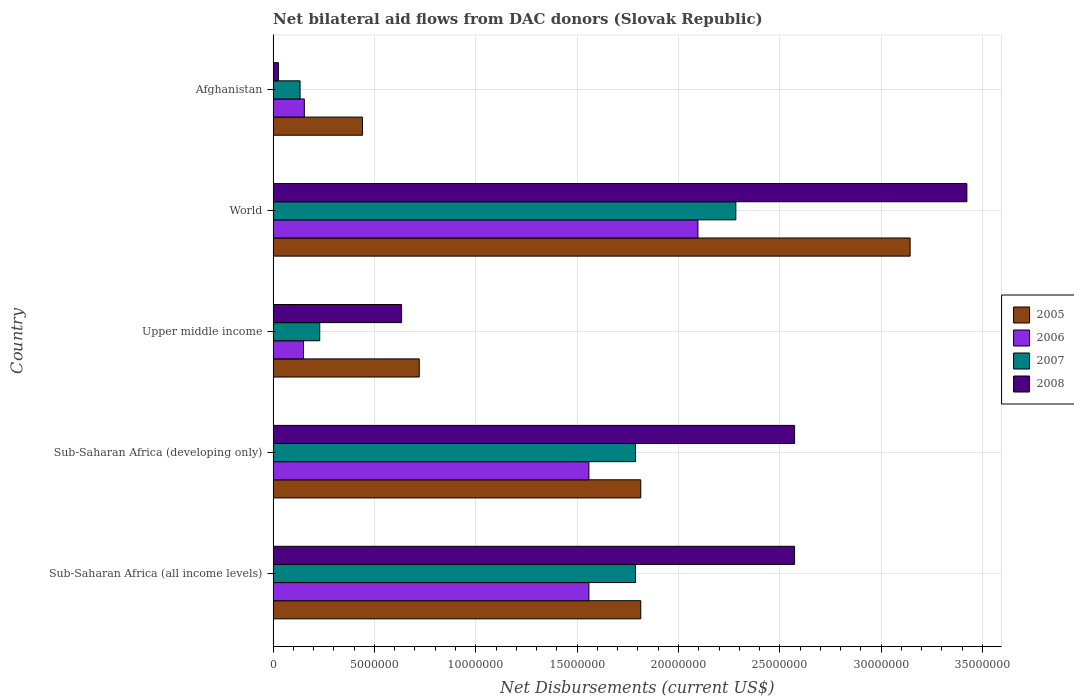How many different coloured bars are there?
Your answer should be compact. 4. Are the number of bars per tick equal to the number of legend labels?
Provide a short and direct response. Yes. Are the number of bars on each tick of the Y-axis equal?
Offer a very short reply. Yes. How many bars are there on the 2nd tick from the top?
Provide a short and direct response. 4. What is the net bilateral aid flows in 2006 in Sub-Saharan Africa (all income levels)?
Make the answer very short. 1.56e+07. Across all countries, what is the maximum net bilateral aid flows in 2005?
Offer a terse response. 3.14e+07. In which country was the net bilateral aid flows in 2005 maximum?
Keep it short and to the point. World. In which country was the net bilateral aid flows in 2006 minimum?
Give a very brief answer. Upper middle income. What is the total net bilateral aid flows in 2005 in the graph?
Ensure brevity in your answer.  7.93e+07. What is the difference between the net bilateral aid flows in 2007 in Upper middle income and that in World?
Ensure brevity in your answer.  -2.05e+07. What is the difference between the net bilateral aid flows in 2006 in Sub-Saharan Africa (all income levels) and the net bilateral aid flows in 2005 in Sub-Saharan Africa (developing only)?
Provide a short and direct response. -2.56e+06. What is the average net bilateral aid flows in 2006 per country?
Provide a succinct answer. 1.10e+07. What is the difference between the net bilateral aid flows in 2008 and net bilateral aid flows in 2006 in Sub-Saharan Africa (all income levels)?
Offer a very short reply. 1.02e+07. What is the ratio of the net bilateral aid flows in 2006 in Afghanistan to that in Sub-Saharan Africa (developing only)?
Give a very brief answer. 0.1. Is the difference between the net bilateral aid flows in 2008 in Afghanistan and Sub-Saharan Africa (developing only) greater than the difference between the net bilateral aid flows in 2006 in Afghanistan and Sub-Saharan Africa (developing only)?
Give a very brief answer. No. What is the difference between the highest and the second highest net bilateral aid flows in 2007?
Your answer should be compact. 4.95e+06. What is the difference between the highest and the lowest net bilateral aid flows in 2008?
Keep it short and to the point. 3.40e+07. In how many countries, is the net bilateral aid flows in 2005 greater than the average net bilateral aid flows in 2005 taken over all countries?
Ensure brevity in your answer.  3. Is the sum of the net bilateral aid flows in 2005 in Sub-Saharan Africa (all income levels) and Sub-Saharan Africa (developing only) greater than the maximum net bilateral aid flows in 2007 across all countries?
Your answer should be compact. Yes. Is it the case that in every country, the sum of the net bilateral aid flows in 2005 and net bilateral aid flows in 2008 is greater than the net bilateral aid flows in 2007?
Your response must be concise. Yes. Are all the bars in the graph horizontal?
Your answer should be compact. Yes. How many countries are there in the graph?
Make the answer very short. 5. Does the graph contain any zero values?
Provide a succinct answer. No. Where does the legend appear in the graph?
Make the answer very short. Center right. What is the title of the graph?
Your response must be concise. Net bilateral aid flows from DAC donors (Slovak Republic). Does "2009" appear as one of the legend labels in the graph?
Give a very brief answer. No. What is the label or title of the X-axis?
Your response must be concise. Net Disbursements (current US$). What is the Net Disbursements (current US$) in 2005 in Sub-Saharan Africa (all income levels)?
Keep it short and to the point. 1.81e+07. What is the Net Disbursements (current US$) in 2006 in Sub-Saharan Africa (all income levels)?
Your answer should be very brief. 1.56e+07. What is the Net Disbursements (current US$) of 2007 in Sub-Saharan Africa (all income levels)?
Provide a succinct answer. 1.79e+07. What is the Net Disbursements (current US$) of 2008 in Sub-Saharan Africa (all income levels)?
Provide a short and direct response. 2.57e+07. What is the Net Disbursements (current US$) in 2005 in Sub-Saharan Africa (developing only)?
Ensure brevity in your answer.  1.81e+07. What is the Net Disbursements (current US$) in 2006 in Sub-Saharan Africa (developing only)?
Make the answer very short. 1.56e+07. What is the Net Disbursements (current US$) of 2007 in Sub-Saharan Africa (developing only)?
Make the answer very short. 1.79e+07. What is the Net Disbursements (current US$) in 2008 in Sub-Saharan Africa (developing only)?
Your answer should be very brief. 2.57e+07. What is the Net Disbursements (current US$) in 2005 in Upper middle income?
Make the answer very short. 7.21e+06. What is the Net Disbursements (current US$) of 2006 in Upper middle income?
Keep it short and to the point. 1.50e+06. What is the Net Disbursements (current US$) in 2007 in Upper middle income?
Offer a terse response. 2.30e+06. What is the Net Disbursements (current US$) of 2008 in Upper middle income?
Your answer should be very brief. 6.34e+06. What is the Net Disbursements (current US$) in 2005 in World?
Give a very brief answer. 3.14e+07. What is the Net Disbursements (current US$) of 2006 in World?
Your answer should be compact. 2.10e+07. What is the Net Disbursements (current US$) in 2007 in World?
Your answer should be very brief. 2.28e+07. What is the Net Disbursements (current US$) in 2008 in World?
Your response must be concise. 3.42e+07. What is the Net Disbursements (current US$) in 2005 in Afghanistan?
Offer a terse response. 4.41e+06. What is the Net Disbursements (current US$) of 2006 in Afghanistan?
Offer a terse response. 1.54e+06. What is the Net Disbursements (current US$) in 2007 in Afghanistan?
Your answer should be compact. 1.33e+06. Across all countries, what is the maximum Net Disbursements (current US$) in 2005?
Provide a succinct answer. 3.14e+07. Across all countries, what is the maximum Net Disbursements (current US$) in 2006?
Make the answer very short. 2.10e+07. Across all countries, what is the maximum Net Disbursements (current US$) in 2007?
Your answer should be compact. 2.28e+07. Across all countries, what is the maximum Net Disbursements (current US$) in 2008?
Offer a very short reply. 3.42e+07. Across all countries, what is the minimum Net Disbursements (current US$) in 2005?
Your answer should be compact. 4.41e+06. Across all countries, what is the minimum Net Disbursements (current US$) in 2006?
Make the answer very short. 1.50e+06. Across all countries, what is the minimum Net Disbursements (current US$) of 2007?
Keep it short and to the point. 1.33e+06. What is the total Net Disbursements (current US$) in 2005 in the graph?
Provide a succinct answer. 7.93e+07. What is the total Net Disbursements (current US$) in 2006 in the graph?
Offer a terse response. 5.52e+07. What is the total Net Disbursements (current US$) of 2007 in the graph?
Make the answer very short. 6.22e+07. What is the total Net Disbursements (current US$) in 2008 in the graph?
Your answer should be compact. 9.23e+07. What is the difference between the Net Disbursements (current US$) of 2005 in Sub-Saharan Africa (all income levels) and that in Upper middle income?
Provide a short and direct response. 1.09e+07. What is the difference between the Net Disbursements (current US$) in 2006 in Sub-Saharan Africa (all income levels) and that in Upper middle income?
Give a very brief answer. 1.41e+07. What is the difference between the Net Disbursements (current US$) of 2007 in Sub-Saharan Africa (all income levels) and that in Upper middle income?
Offer a terse response. 1.56e+07. What is the difference between the Net Disbursements (current US$) in 2008 in Sub-Saharan Africa (all income levels) and that in Upper middle income?
Your answer should be very brief. 1.94e+07. What is the difference between the Net Disbursements (current US$) of 2005 in Sub-Saharan Africa (all income levels) and that in World?
Your response must be concise. -1.33e+07. What is the difference between the Net Disbursements (current US$) of 2006 in Sub-Saharan Africa (all income levels) and that in World?
Your answer should be compact. -5.38e+06. What is the difference between the Net Disbursements (current US$) in 2007 in Sub-Saharan Africa (all income levels) and that in World?
Make the answer very short. -4.95e+06. What is the difference between the Net Disbursements (current US$) of 2008 in Sub-Saharan Africa (all income levels) and that in World?
Provide a succinct answer. -8.50e+06. What is the difference between the Net Disbursements (current US$) of 2005 in Sub-Saharan Africa (all income levels) and that in Afghanistan?
Ensure brevity in your answer.  1.37e+07. What is the difference between the Net Disbursements (current US$) in 2006 in Sub-Saharan Africa (all income levels) and that in Afghanistan?
Offer a terse response. 1.40e+07. What is the difference between the Net Disbursements (current US$) of 2007 in Sub-Saharan Africa (all income levels) and that in Afghanistan?
Provide a short and direct response. 1.66e+07. What is the difference between the Net Disbursements (current US$) of 2008 in Sub-Saharan Africa (all income levels) and that in Afghanistan?
Keep it short and to the point. 2.55e+07. What is the difference between the Net Disbursements (current US$) of 2005 in Sub-Saharan Africa (developing only) and that in Upper middle income?
Make the answer very short. 1.09e+07. What is the difference between the Net Disbursements (current US$) in 2006 in Sub-Saharan Africa (developing only) and that in Upper middle income?
Ensure brevity in your answer.  1.41e+07. What is the difference between the Net Disbursements (current US$) of 2007 in Sub-Saharan Africa (developing only) and that in Upper middle income?
Give a very brief answer. 1.56e+07. What is the difference between the Net Disbursements (current US$) in 2008 in Sub-Saharan Africa (developing only) and that in Upper middle income?
Your response must be concise. 1.94e+07. What is the difference between the Net Disbursements (current US$) of 2005 in Sub-Saharan Africa (developing only) and that in World?
Ensure brevity in your answer.  -1.33e+07. What is the difference between the Net Disbursements (current US$) of 2006 in Sub-Saharan Africa (developing only) and that in World?
Ensure brevity in your answer.  -5.38e+06. What is the difference between the Net Disbursements (current US$) in 2007 in Sub-Saharan Africa (developing only) and that in World?
Ensure brevity in your answer.  -4.95e+06. What is the difference between the Net Disbursements (current US$) in 2008 in Sub-Saharan Africa (developing only) and that in World?
Ensure brevity in your answer.  -8.50e+06. What is the difference between the Net Disbursements (current US$) of 2005 in Sub-Saharan Africa (developing only) and that in Afghanistan?
Provide a short and direct response. 1.37e+07. What is the difference between the Net Disbursements (current US$) of 2006 in Sub-Saharan Africa (developing only) and that in Afghanistan?
Your response must be concise. 1.40e+07. What is the difference between the Net Disbursements (current US$) of 2007 in Sub-Saharan Africa (developing only) and that in Afghanistan?
Keep it short and to the point. 1.66e+07. What is the difference between the Net Disbursements (current US$) of 2008 in Sub-Saharan Africa (developing only) and that in Afghanistan?
Provide a short and direct response. 2.55e+07. What is the difference between the Net Disbursements (current US$) of 2005 in Upper middle income and that in World?
Your answer should be very brief. -2.42e+07. What is the difference between the Net Disbursements (current US$) in 2006 in Upper middle income and that in World?
Provide a succinct answer. -1.95e+07. What is the difference between the Net Disbursements (current US$) of 2007 in Upper middle income and that in World?
Ensure brevity in your answer.  -2.05e+07. What is the difference between the Net Disbursements (current US$) of 2008 in Upper middle income and that in World?
Offer a very short reply. -2.79e+07. What is the difference between the Net Disbursements (current US$) of 2005 in Upper middle income and that in Afghanistan?
Offer a very short reply. 2.80e+06. What is the difference between the Net Disbursements (current US$) in 2007 in Upper middle income and that in Afghanistan?
Keep it short and to the point. 9.70e+05. What is the difference between the Net Disbursements (current US$) of 2008 in Upper middle income and that in Afghanistan?
Keep it short and to the point. 6.08e+06. What is the difference between the Net Disbursements (current US$) in 2005 in World and that in Afghanistan?
Offer a terse response. 2.70e+07. What is the difference between the Net Disbursements (current US$) of 2006 in World and that in Afghanistan?
Provide a succinct answer. 1.94e+07. What is the difference between the Net Disbursements (current US$) of 2007 in World and that in Afghanistan?
Your answer should be compact. 2.15e+07. What is the difference between the Net Disbursements (current US$) of 2008 in World and that in Afghanistan?
Offer a very short reply. 3.40e+07. What is the difference between the Net Disbursements (current US$) of 2005 in Sub-Saharan Africa (all income levels) and the Net Disbursements (current US$) of 2006 in Sub-Saharan Africa (developing only)?
Offer a very short reply. 2.56e+06. What is the difference between the Net Disbursements (current US$) in 2005 in Sub-Saharan Africa (all income levels) and the Net Disbursements (current US$) in 2007 in Sub-Saharan Africa (developing only)?
Your response must be concise. 2.60e+05. What is the difference between the Net Disbursements (current US$) in 2005 in Sub-Saharan Africa (all income levels) and the Net Disbursements (current US$) in 2008 in Sub-Saharan Africa (developing only)?
Offer a terse response. -7.59e+06. What is the difference between the Net Disbursements (current US$) in 2006 in Sub-Saharan Africa (all income levels) and the Net Disbursements (current US$) in 2007 in Sub-Saharan Africa (developing only)?
Offer a terse response. -2.30e+06. What is the difference between the Net Disbursements (current US$) of 2006 in Sub-Saharan Africa (all income levels) and the Net Disbursements (current US$) of 2008 in Sub-Saharan Africa (developing only)?
Your answer should be compact. -1.02e+07. What is the difference between the Net Disbursements (current US$) in 2007 in Sub-Saharan Africa (all income levels) and the Net Disbursements (current US$) in 2008 in Sub-Saharan Africa (developing only)?
Give a very brief answer. -7.85e+06. What is the difference between the Net Disbursements (current US$) of 2005 in Sub-Saharan Africa (all income levels) and the Net Disbursements (current US$) of 2006 in Upper middle income?
Keep it short and to the point. 1.66e+07. What is the difference between the Net Disbursements (current US$) in 2005 in Sub-Saharan Africa (all income levels) and the Net Disbursements (current US$) in 2007 in Upper middle income?
Ensure brevity in your answer.  1.58e+07. What is the difference between the Net Disbursements (current US$) of 2005 in Sub-Saharan Africa (all income levels) and the Net Disbursements (current US$) of 2008 in Upper middle income?
Provide a short and direct response. 1.18e+07. What is the difference between the Net Disbursements (current US$) in 2006 in Sub-Saharan Africa (all income levels) and the Net Disbursements (current US$) in 2007 in Upper middle income?
Ensure brevity in your answer.  1.33e+07. What is the difference between the Net Disbursements (current US$) in 2006 in Sub-Saharan Africa (all income levels) and the Net Disbursements (current US$) in 2008 in Upper middle income?
Provide a succinct answer. 9.24e+06. What is the difference between the Net Disbursements (current US$) in 2007 in Sub-Saharan Africa (all income levels) and the Net Disbursements (current US$) in 2008 in Upper middle income?
Provide a succinct answer. 1.15e+07. What is the difference between the Net Disbursements (current US$) in 2005 in Sub-Saharan Africa (all income levels) and the Net Disbursements (current US$) in 2006 in World?
Ensure brevity in your answer.  -2.82e+06. What is the difference between the Net Disbursements (current US$) in 2005 in Sub-Saharan Africa (all income levels) and the Net Disbursements (current US$) in 2007 in World?
Provide a short and direct response. -4.69e+06. What is the difference between the Net Disbursements (current US$) in 2005 in Sub-Saharan Africa (all income levels) and the Net Disbursements (current US$) in 2008 in World?
Provide a succinct answer. -1.61e+07. What is the difference between the Net Disbursements (current US$) of 2006 in Sub-Saharan Africa (all income levels) and the Net Disbursements (current US$) of 2007 in World?
Provide a short and direct response. -7.25e+06. What is the difference between the Net Disbursements (current US$) in 2006 in Sub-Saharan Africa (all income levels) and the Net Disbursements (current US$) in 2008 in World?
Make the answer very short. -1.86e+07. What is the difference between the Net Disbursements (current US$) in 2007 in Sub-Saharan Africa (all income levels) and the Net Disbursements (current US$) in 2008 in World?
Make the answer very short. -1.64e+07. What is the difference between the Net Disbursements (current US$) of 2005 in Sub-Saharan Africa (all income levels) and the Net Disbursements (current US$) of 2006 in Afghanistan?
Offer a very short reply. 1.66e+07. What is the difference between the Net Disbursements (current US$) in 2005 in Sub-Saharan Africa (all income levels) and the Net Disbursements (current US$) in 2007 in Afghanistan?
Ensure brevity in your answer.  1.68e+07. What is the difference between the Net Disbursements (current US$) of 2005 in Sub-Saharan Africa (all income levels) and the Net Disbursements (current US$) of 2008 in Afghanistan?
Offer a very short reply. 1.79e+07. What is the difference between the Net Disbursements (current US$) in 2006 in Sub-Saharan Africa (all income levels) and the Net Disbursements (current US$) in 2007 in Afghanistan?
Provide a short and direct response. 1.42e+07. What is the difference between the Net Disbursements (current US$) of 2006 in Sub-Saharan Africa (all income levels) and the Net Disbursements (current US$) of 2008 in Afghanistan?
Your response must be concise. 1.53e+07. What is the difference between the Net Disbursements (current US$) in 2007 in Sub-Saharan Africa (all income levels) and the Net Disbursements (current US$) in 2008 in Afghanistan?
Your answer should be very brief. 1.76e+07. What is the difference between the Net Disbursements (current US$) of 2005 in Sub-Saharan Africa (developing only) and the Net Disbursements (current US$) of 2006 in Upper middle income?
Make the answer very short. 1.66e+07. What is the difference between the Net Disbursements (current US$) of 2005 in Sub-Saharan Africa (developing only) and the Net Disbursements (current US$) of 2007 in Upper middle income?
Offer a very short reply. 1.58e+07. What is the difference between the Net Disbursements (current US$) of 2005 in Sub-Saharan Africa (developing only) and the Net Disbursements (current US$) of 2008 in Upper middle income?
Ensure brevity in your answer.  1.18e+07. What is the difference between the Net Disbursements (current US$) of 2006 in Sub-Saharan Africa (developing only) and the Net Disbursements (current US$) of 2007 in Upper middle income?
Keep it short and to the point. 1.33e+07. What is the difference between the Net Disbursements (current US$) of 2006 in Sub-Saharan Africa (developing only) and the Net Disbursements (current US$) of 2008 in Upper middle income?
Provide a short and direct response. 9.24e+06. What is the difference between the Net Disbursements (current US$) of 2007 in Sub-Saharan Africa (developing only) and the Net Disbursements (current US$) of 2008 in Upper middle income?
Give a very brief answer. 1.15e+07. What is the difference between the Net Disbursements (current US$) of 2005 in Sub-Saharan Africa (developing only) and the Net Disbursements (current US$) of 2006 in World?
Make the answer very short. -2.82e+06. What is the difference between the Net Disbursements (current US$) of 2005 in Sub-Saharan Africa (developing only) and the Net Disbursements (current US$) of 2007 in World?
Provide a short and direct response. -4.69e+06. What is the difference between the Net Disbursements (current US$) of 2005 in Sub-Saharan Africa (developing only) and the Net Disbursements (current US$) of 2008 in World?
Your response must be concise. -1.61e+07. What is the difference between the Net Disbursements (current US$) in 2006 in Sub-Saharan Africa (developing only) and the Net Disbursements (current US$) in 2007 in World?
Give a very brief answer. -7.25e+06. What is the difference between the Net Disbursements (current US$) in 2006 in Sub-Saharan Africa (developing only) and the Net Disbursements (current US$) in 2008 in World?
Your answer should be compact. -1.86e+07. What is the difference between the Net Disbursements (current US$) of 2007 in Sub-Saharan Africa (developing only) and the Net Disbursements (current US$) of 2008 in World?
Offer a terse response. -1.64e+07. What is the difference between the Net Disbursements (current US$) in 2005 in Sub-Saharan Africa (developing only) and the Net Disbursements (current US$) in 2006 in Afghanistan?
Provide a short and direct response. 1.66e+07. What is the difference between the Net Disbursements (current US$) in 2005 in Sub-Saharan Africa (developing only) and the Net Disbursements (current US$) in 2007 in Afghanistan?
Ensure brevity in your answer.  1.68e+07. What is the difference between the Net Disbursements (current US$) of 2005 in Sub-Saharan Africa (developing only) and the Net Disbursements (current US$) of 2008 in Afghanistan?
Your answer should be very brief. 1.79e+07. What is the difference between the Net Disbursements (current US$) of 2006 in Sub-Saharan Africa (developing only) and the Net Disbursements (current US$) of 2007 in Afghanistan?
Offer a very short reply. 1.42e+07. What is the difference between the Net Disbursements (current US$) in 2006 in Sub-Saharan Africa (developing only) and the Net Disbursements (current US$) in 2008 in Afghanistan?
Provide a short and direct response. 1.53e+07. What is the difference between the Net Disbursements (current US$) in 2007 in Sub-Saharan Africa (developing only) and the Net Disbursements (current US$) in 2008 in Afghanistan?
Keep it short and to the point. 1.76e+07. What is the difference between the Net Disbursements (current US$) of 2005 in Upper middle income and the Net Disbursements (current US$) of 2006 in World?
Ensure brevity in your answer.  -1.38e+07. What is the difference between the Net Disbursements (current US$) in 2005 in Upper middle income and the Net Disbursements (current US$) in 2007 in World?
Provide a short and direct response. -1.56e+07. What is the difference between the Net Disbursements (current US$) of 2005 in Upper middle income and the Net Disbursements (current US$) of 2008 in World?
Provide a short and direct response. -2.70e+07. What is the difference between the Net Disbursements (current US$) of 2006 in Upper middle income and the Net Disbursements (current US$) of 2007 in World?
Offer a terse response. -2.13e+07. What is the difference between the Net Disbursements (current US$) of 2006 in Upper middle income and the Net Disbursements (current US$) of 2008 in World?
Offer a very short reply. -3.27e+07. What is the difference between the Net Disbursements (current US$) of 2007 in Upper middle income and the Net Disbursements (current US$) of 2008 in World?
Offer a very short reply. -3.19e+07. What is the difference between the Net Disbursements (current US$) of 2005 in Upper middle income and the Net Disbursements (current US$) of 2006 in Afghanistan?
Provide a short and direct response. 5.67e+06. What is the difference between the Net Disbursements (current US$) of 2005 in Upper middle income and the Net Disbursements (current US$) of 2007 in Afghanistan?
Your response must be concise. 5.88e+06. What is the difference between the Net Disbursements (current US$) in 2005 in Upper middle income and the Net Disbursements (current US$) in 2008 in Afghanistan?
Your response must be concise. 6.95e+06. What is the difference between the Net Disbursements (current US$) in 2006 in Upper middle income and the Net Disbursements (current US$) in 2007 in Afghanistan?
Keep it short and to the point. 1.70e+05. What is the difference between the Net Disbursements (current US$) of 2006 in Upper middle income and the Net Disbursements (current US$) of 2008 in Afghanistan?
Give a very brief answer. 1.24e+06. What is the difference between the Net Disbursements (current US$) of 2007 in Upper middle income and the Net Disbursements (current US$) of 2008 in Afghanistan?
Ensure brevity in your answer.  2.04e+06. What is the difference between the Net Disbursements (current US$) of 2005 in World and the Net Disbursements (current US$) of 2006 in Afghanistan?
Offer a terse response. 2.99e+07. What is the difference between the Net Disbursements (current US$) of 2005 in World and the Net Disbursements (current US$) of 2007 in Afghanistan?
Your response must be concise. 3.01e+07. What is the difference between the Net Disbursements (current US$) in 2005 in World and the Net Disbursements (current US$) in 2008 in Afghanistan?
Offer a terse response. 3.12e+07. What is the difference between the Net Disbursements (current US$) in 2006 in World and the Net Disbursements (current US$) in 2007 in Afghanistan?
Offer a very short reply. 1.96e+07. What is the difference between the Net Disbursements (current US$) of 2006 in World and the Net Disbursements (current US$) of 2008 in Afghanistan?
Offer a very short reply. 2.07e+07. What is the difference between the Net Disbursements (current US$) of 2007 in World and the Net Disbursements (current US$) of 2008 in Afghanistan?
Keep it short and to the point. 2.26e+07. What is the average Net Disbursements (current US$) of 2005 per country?
Provide a short and direct response. 1.59e+07. What is the average Net Disbursements (current US$) in 2006 per country?
Offer a terse response. 1.10e+07. What is the average Net Disbursements (current US$) in 2007 per country?
Provide a succinct answer. 1.24e+07. What is the average Net Disbursements (current US$) in 2008 per country?
Give a very brief answer. 1.85e+07. What is the difference between the Net Disbursements (current US$) in 2005 and Net Disbursements (current US$) in 2006 in Sub-Saharan Africa (all income levels)?
Provide a succinct answer. 2.56e+06. What is the difference between the Net Disbursements (current US$) of 2005 and Net Disbursements (current US$) of 2008 in Sub-Saharan Africa (all income levels)?
Your answer should be compact. -7.59e+06. What is the difference between the Net Disbursements (current US$) of 2006 and Net Disbursements (current US$) of 2007 in Sub-Saharan Africa (all income levels)?
Give a very brief answer. -2.30e+06. What is the difference between the Net Disbursements (current US$) of 2006 and Net Disbursements (current US$) of 2008 in Sub-Saharan Africa (all income levels)?
Offer a terse response. -1.02e+07. What is the difference between the Net Disbursements (current US$) of 2007 and Net Disbursements (current US$) of 2008 in Sub-Saharan Africa (all income levels)?
Offer a terse response. -7.85e+06. What is the difference between the Net Disbursements (current US$) in 2005 and Net Disbursements (current US$) in 2006 in Sub-Saharan Africa (developing only)?
Make the answer very short. 2.56e+06. What is the difference between the Net Disbursements (current US$) in 2005 and Net Disbursements (current US$) in 2008 in Sub-Saharan Africa (developing only)?
Provide a short and direct response. -7.59e+06. What is the difference between the Net Disbursements (current US$) of 2006 and Net Disbursements (current US$) of 2007 in Sub-Saharan Africa (developing only)?
Keep it short and to the point. -2.30e+06. What is the difference between the Net Disbursements (current US$) in 2006 and Net Disbursements (current US$) in 2008 in Sub-Saharan Africa (developing only)?
Your answer should be very brief. -1.02e+07. What is the difference between the Net Disbursements (current US$) in 2007 and Net Disbursements (current US$) in 2008 in Sub-Saharan Africa (developing only)?
Offer a very short reply. -7.85e+06. What is the difference between the Net Disbursements (current US$) in 2005 and Net Disbursements (current US$) in 2006 in Upper middle income?
Keep it short and to the point. 5.71e+06. What is the difference between the Net Disbursements (current US$) in 2005 and Net Disbursements (current US$) in 2007 in Upper middle income?
Keep it short and to the point. 4.91e+06. What is the difference between the Net Disbursements (current US$) in 2005 and Net Disbursements (current US$) in 2008 in Upper middle income?
Make the answer very short. 8.70e+05. What is the difference between the Net Disbursements (current US$) of 2006 and Net Disbursements (current US$) of 2007 in Upper middle income?
Your response must be concise. -8.00e+05. What is the difference between the Net Disbursements (current US$) in 2006 and Net Disbursements (current US$) in 2008 in Upper middle income?
Provide a short and direct response. -4.84e+06. What is the difference between the Net Disbursements (current US$) in 2007 and Net Disbursements (current US$) in 2008 in Upper middle income?
Ensure brevity in your answer.  -4.04e+06. What is the difference between the Net Disbursements (current US$) in 2005 and Net Disbursements (current US$) in 2006 in World?
Ensure brevity in your answer.  1.05e+07. What is the difference between the Net Disbursements (current US$) in 2005 and Net Disbursements (current US$) in 2007 in World?
Offer a very short reply. 8.60e+06. What is the difference between the Net Disbursements (current US$) in 2005 and Net Disbursements (current US$) in 2008 in World?
Provide a short and direct response. -2.80e+06. What is the difference between the Net Disbursements (current US$) of 2006 and Net Disbursements (current US$) of 2007 in World?
Make the answer very short. -1.87e+06. What is the difference between the Net Disbursements (current US$) in 2006 and Net Disbursements (current US$) in 2008 in World?
Provide a short and direct response. -1.33e+07. What is the difference between the Net Disbursements (current US$) in 2007 and Net Disbursements (current US$) in 2008 in World?
Provide a succinct answer. -1.14e+07. What is the difference between the Net Disbursements (current US$) in 2005 and Net Disbursements (current US$) in 2006 in Afghanistan?
Your answer should be compact. 2.87e+06. What is the difference between the Net Disbursements (current US$) in 2005 and Net Disbursements (current US$) in 2007 in Afghanistan?
Give a very brief answer. 3.08e+06. What is the difference between the Net Disbursements (current US$) in 2005 and Net Disbursements (current US$) in 2008 in Afghanistan?
Keep it short and to the point. 4.15e+06. What is the difference between the Net Disbursements (current US$) in 2006 and Net Disbursements (current US$) in 2007 in Afghanistan?
Provide a succinct answer. 2.10e+05. What is the difference between the Net Disbursements (current US$) of 2006 and Net Disbursements (current US$) of 2008 in Afghanistan?
Provide a succinct answer. 1.28e+06. What is the difference between the Net Disbursements (current US$) of 2007 and Net Disbursements (current US$) of 2008 in Afghanistan?
Your answer should be compact. 1.07e+06. What is the ratio of the Net Disbursements (current US$) of 2005 in Sub-Saharan Africa (all income levels) to that in Sub-Saharan Africa (developing only)?
Ensure brevity in your answer.  1. What is the ratio of the Net Disbursements (current US$) in 2007 in Sub-Saharan Africa (all income levels) to that in Sub-Saharan Africa (developing only)?
Keep it short and to the point. 1. What is the ratio of the Net Disbursements (current US$) in 2005 in Sub-Saharan Africa (all income levels) to that in Upper middle income?
Your answer should be compact. 2.52. What is the ratio of the Net Disbursements (current US$) in 2006 in Sub-Saharan Africa (all income levels) to that in Upper middle income?
Provide a succinct answer. 10.39. What is the ratio of the Net Disbursements (current US$) of 2007 in Sub-Saharan Africa (all income levels) to that in Upper middle income?
Give a very brief answer. 7.77. What is the ratio of the Net Disbursements (current US$) in 2008 in Sub-Saharan Africa (all income levels) to that in Upper middle income?
Ensure brevity in your answer.  4.06. What is the ratio of the Net Disbursements (current US$) of 2005 in Sub-Saharan Africa (all income levels) to that in World?
Your response must be concise. 0.58. What is the ratio of the Net Disbursements (current US$) in 2006 in Sub-Saharan Africa (all income levels) to that in World?
Your response must be concise. 0.74. What is the ratio of the Net Disbursements (current US$) of 2007 in Sub-Saharan Africa (all income levels) to that in World?
Give a very brief answer. 0.78. What is the ratio of the Net Disbursements (current US$) of 2008 in Sub-Saharan Africa (all income levels) to that in World?
Give a very brief answer. 0.75. What is the ratio of the Net Disbursements (current US$) in 2005 in Sub-Saharan Africa (all income levels) to that in Afghanistan?
Keep it short and to the point. 4.11. What is the ratio of the Net Disbursements (current US$) in 2006 in Sub-Saharan Africa (all income levels) to that in Afghanistan?
Your answer should be compact. 10.12. What is the ratio of the Net Disbursements (current US$) in 2007 in Sub-Saharan Africa (all income levels) to that in Afghanistan?
Provide a short and direct response. 13.44. What is the ratio of the Net Disbursements (current US$) of 2008 in Sub-Saharan Africa (all income levels) to that in Afghanistan?
Provide a succinct answer. 98.96. What is the ratio of the Net Disbursements (current US$) of 2005 in Sub-Saharan Africa (developing only) to that in Upper middle income?
Make the answer very short. 2.52. What is the ratio of the Net Disbursements (current US$) of 2006 in Sub-Saharan Africa (developing only) to that in Upper middle income?
Your answer should be very brief. 10.39. What is the ratio of the Net Disbursements (current US$) in 2007 in Sub-Saharan Africa (developing only) to that in Upper middle income?
Offer a terse response. 7.77. What is the ratio of the Net Disbursements (current US$) in 2008 in Sub-Saharan Africa (developing only) to that in Upper middle income?
Keep it short and to the point. 4.06. What is the ratio of the Net Disbursements (current US$) of 2005 in Sub-Saharan Africa (developing only) to that in World?
Provide a short and direct response. 0.58. What is the ratio of the Net Disbursements (current US$) of 2006 in Sub-Saharan Africa (developing only) to that in World?
Ensure brevity in your answer.  0.74. What is the ratio of the Net Disbursements (current US$) in 2007 in Sub-Saharan Africa (developing only) to that in World?
Your answer should be compact. 0.78. What is the ratio of the Net Disbursements (current US$) in 2008 in Sub-Saharan Africa (developing only) to that in World?
Provide a succinct answer. 0.75. What is the ratio of the Net Disbursements (current US$) in 2005 in Sub-Saharan Africa (developing only) to that in Afghanistan?
Ensure brevity in your answer.  4.11. What is the ratio of the Net Disbursements (current US$) in 2006 in Sub-Saharan Africa (developing only) to that in Afghanistan?
Make the answer very short. 10.12. What is the ratio of the Net Disbursements (current US$) of 2007 in Sub-Saharan Africa (developing only) to that in Afghanistan?
Your answer should be very brief. 13.44. What is the ratio of the Net Disbursements (current US$) of 2008 in Sub-Saharan Africa (developing only) to that in Afghanistan?
Offer a terse response. 98.96. What is the ratio of the Net Disbursements (current US$) of 2005 in Upper middle income to that in World?
Provide a succinct answer. 0.23. What is the ratio of the Net Disbursements (current US$) of 2006 in Upper middle income to that in World?
Give a very brief answer. 0.07. What is the ratio of the Net Disbursements (current US$) of 2007 in Upper middle income to that in World?
Make the answer very short. 0.1. What is the ratio of the Net Disbursements (current US$) in 2008 in Upper middle income to that in World?
Your answer should be compact. 0.19. What is the ratio of the Net Disbursements (current US$) in 2005 in Upper middle income to that in Afghanistan?
Your response must be concise. 1.63. What is the ratio of the Net Disbursements (current US$) of 2007 in Upper middle income to that in Afghanistan?
Offer a very short reply. 1.73. What is the ratio of the Net Disbursements (current US$) of 2008 in Upper middle income to that in Afghanistan?
Provide a short and direct response. 24.38. What is the ratio of the Net Disbursements (current US$) in 2005 in World to that in Afghanistan?
Provide a short and direct response. 7.13. What is the ratio of the Net Disbursements (current US$) in 2006 in World to that in Afghanistan?
Your answer should be very brief. 13.61. What is the ratio of the Net Disbursements (current US$) of 2007 in World to that in Afghanistan?
Offer a terse response. 17.17. What is the ratio of the Net Disbursements (current US$) of 2008 in World to that in Afghanistan?
Provide a succinct answer. 131.65. What is the difference between the highest and the second highest Net Disbursements (current US$) in 2005?
Offer a very short reply. 1.33e+07. What is the difference between the highest and the second highest Net Disbursements (current US$) of 2006?
Provide a short and direct response. 5.38e+06. What is the difference between the highest and the second highest Net Disbursements (current US$) of 2007?
Ensure brevity in your answer.  4.95e+06. What is the difference between the highest and the second highest Net Disbursements (current US$) in 2008?
Your response must be concise. 8.50e+06. What is the difference between the highest and the lowest Net Disbursements (current US$) in 2005?
Provide a short and direct response. 2.70e+07. What is the difference between the highest and the lowest Net Disbursements (current US$) in 2006?
Offer a terse response. 1.95e+07. What is the difference between the highest and the lowest Net Disbursements (current US$) of 2007?
Keep it short and to the point. 2.15e+07. What is the difference between the highest and the lowest Net Disbursements (current US$) in 2008?
Your answer should be very brief. 3.40e+07. 